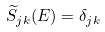Convert formula to latex. <formula><loc_0><loc_0><loc_500><loc_500>\widetilde { S } _ { j k } ( E ) = \delta _ { j k }</formula> 